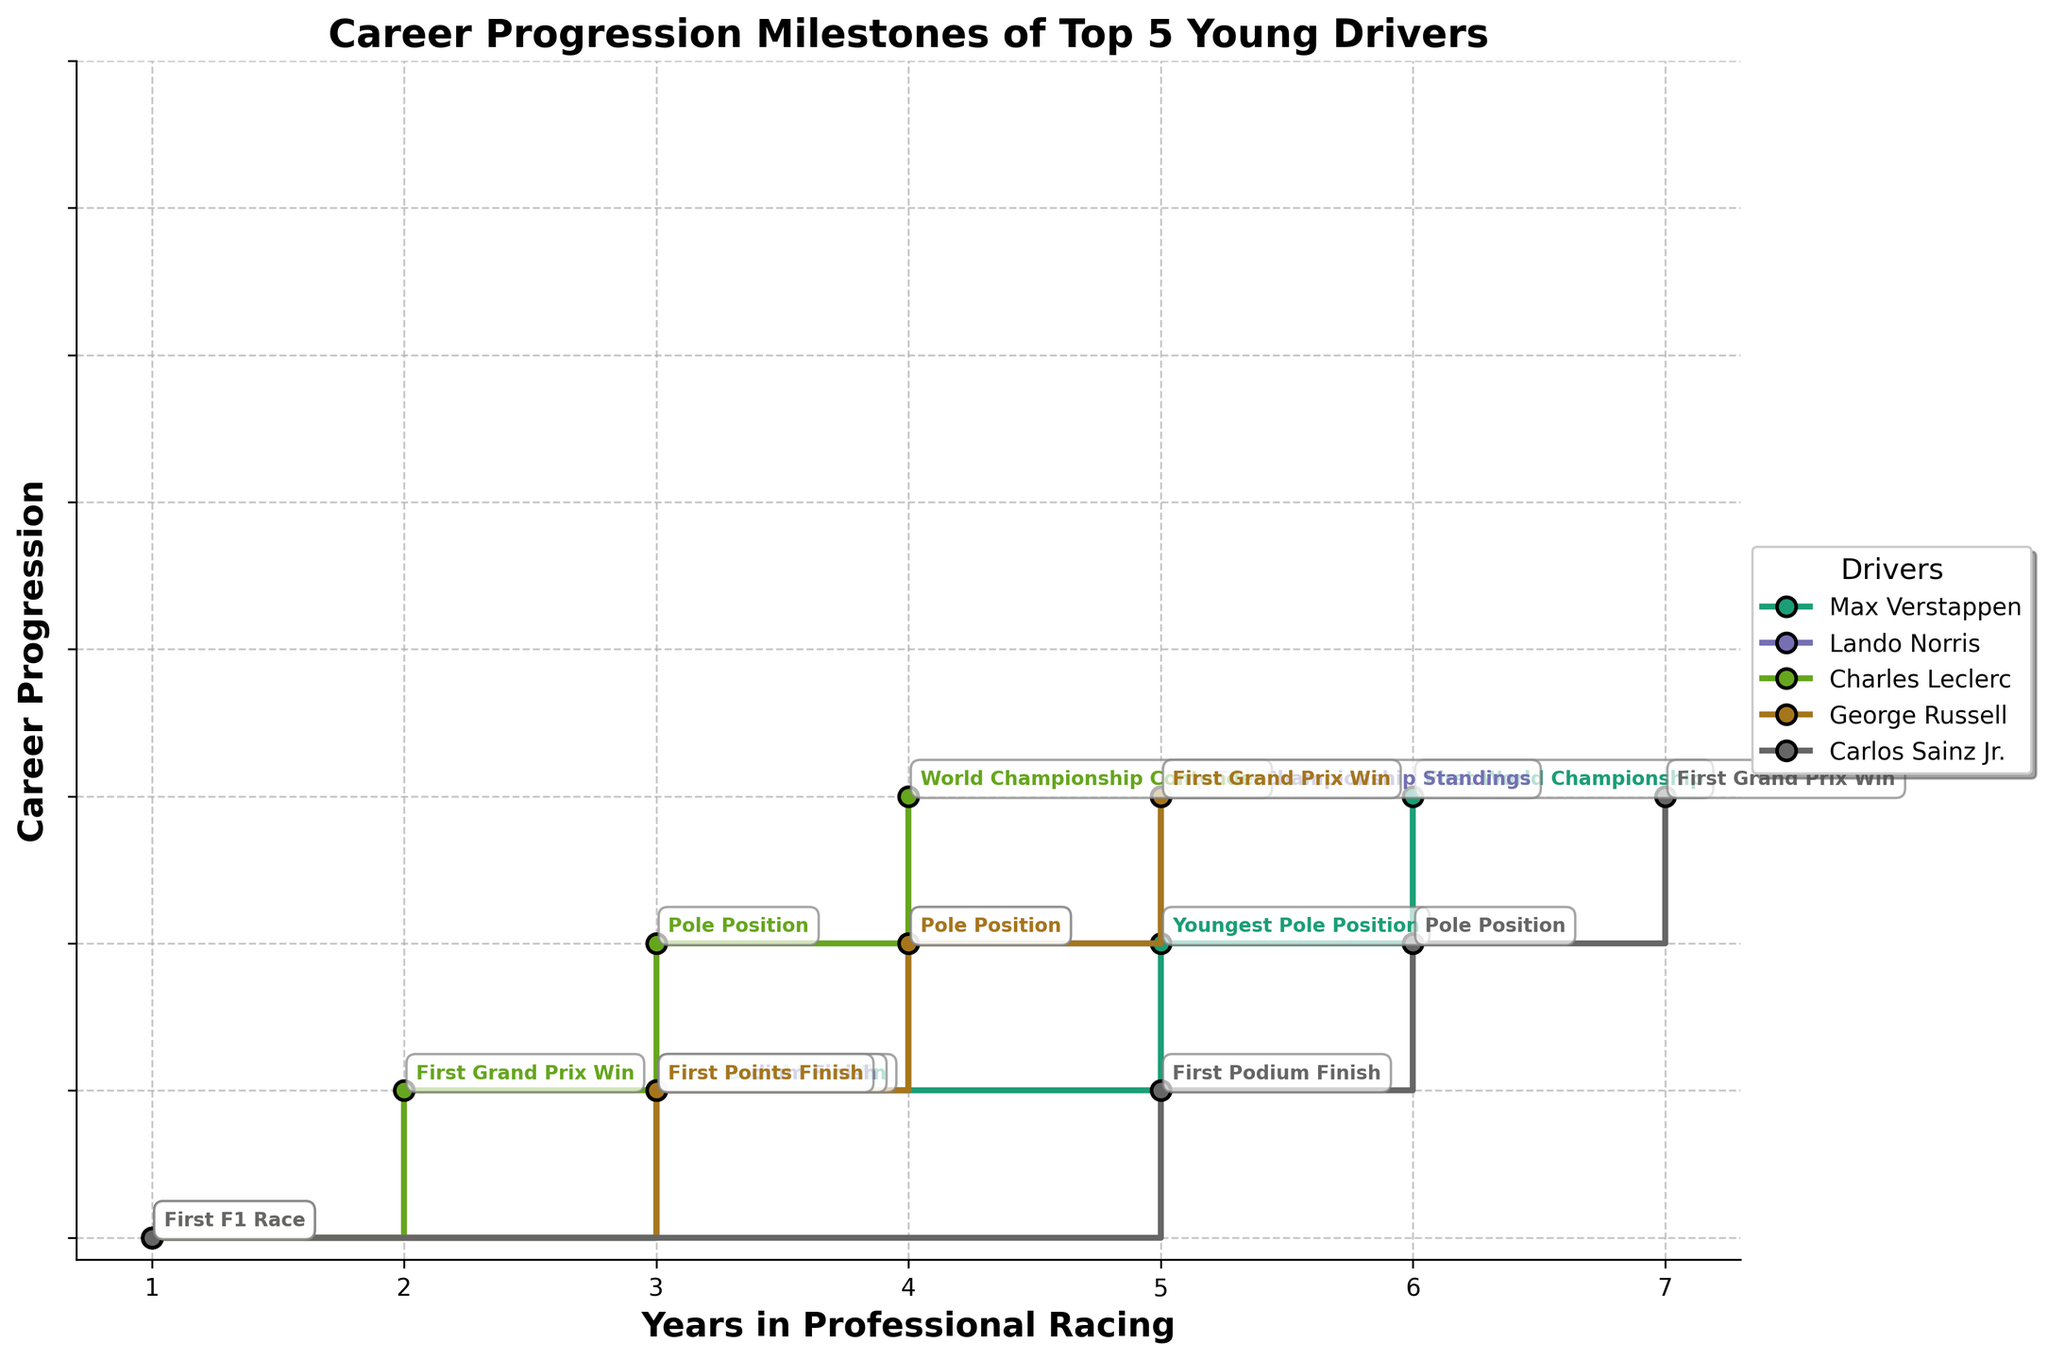Who was the first driver to win a Grand Prix? According to the plot, Charles Leclerc won a Grand Prix in his second year, which is earlier than any other driver who achieved the same milestone.
Answer: Charles Leclerc Which driver reached their first Grand Prix win the earliest in their career? By comparing the years in which the drivers achieved their first Grand Prix win, Charles Leclerc achieved it in his second year, which is earlier than the others.
Answer: Charles Leclerc Who achieved the "Pole Position" milestone first in their career? Charles Leclerc achieved a "Pole Position" in his third year, which is earlier than any other driver.
Answer: Charles Leclerc How many years after his first race did George Russell achieve his first Grand Prix win? George Russell had his first F1 race in his first year and achieved his first Grand Prix win in his fifth year. The difference is 5 - 1 = 4 years.
Answer: 4 years Who had the longest time between their first F1 race and achieving "Pole Position"? Carlos Sainz Jr. had his first F1 race in his first year and achieved "Pole Position" in his sixth year. The time difference is 6 - 1 = 5 years.
Answer: Carlos Sainz Jr Which driver had the shortest progression from their first Grand Prix win to becoming a World Championship contender? Charles Leclerc became a World Championship contender in his fourth year and had his first Grand Prix win in his second year. The progression time is 4 - 2 = 2 years.
Answer: Charles Leclerc Based on the milestones achieved, which driver has the most consistent yearly progression? Max Verstappen shows a consistent progression with significant milestones almost every year up to his sixth year: First F1 Race (Year 1), First Grand Prix Win (Year 3), Youngest Pole Position (Year 5), First World Championship (Year 6).
Answer: Max Verstappen Who took the longest to win their first Grand Prix after starting their F1 career? Carlos Sainz Jr. won his first Grand Prix in his seventh year since his first F1 race. This is the longest duration among the drivers.
Answer: Carlos Sainz Jr Which driver achieved significant milestones in both the third and fourth years of their career? Both Charles Leclerc and George Russell achieved significant milestones in their third and fourth years. Charles Leclerc had a Grand Prix win and a Pole Position, and George Russell had a Points Finish and a Pole Position in those years.
Answer: Charles Leclerc and George Russell 